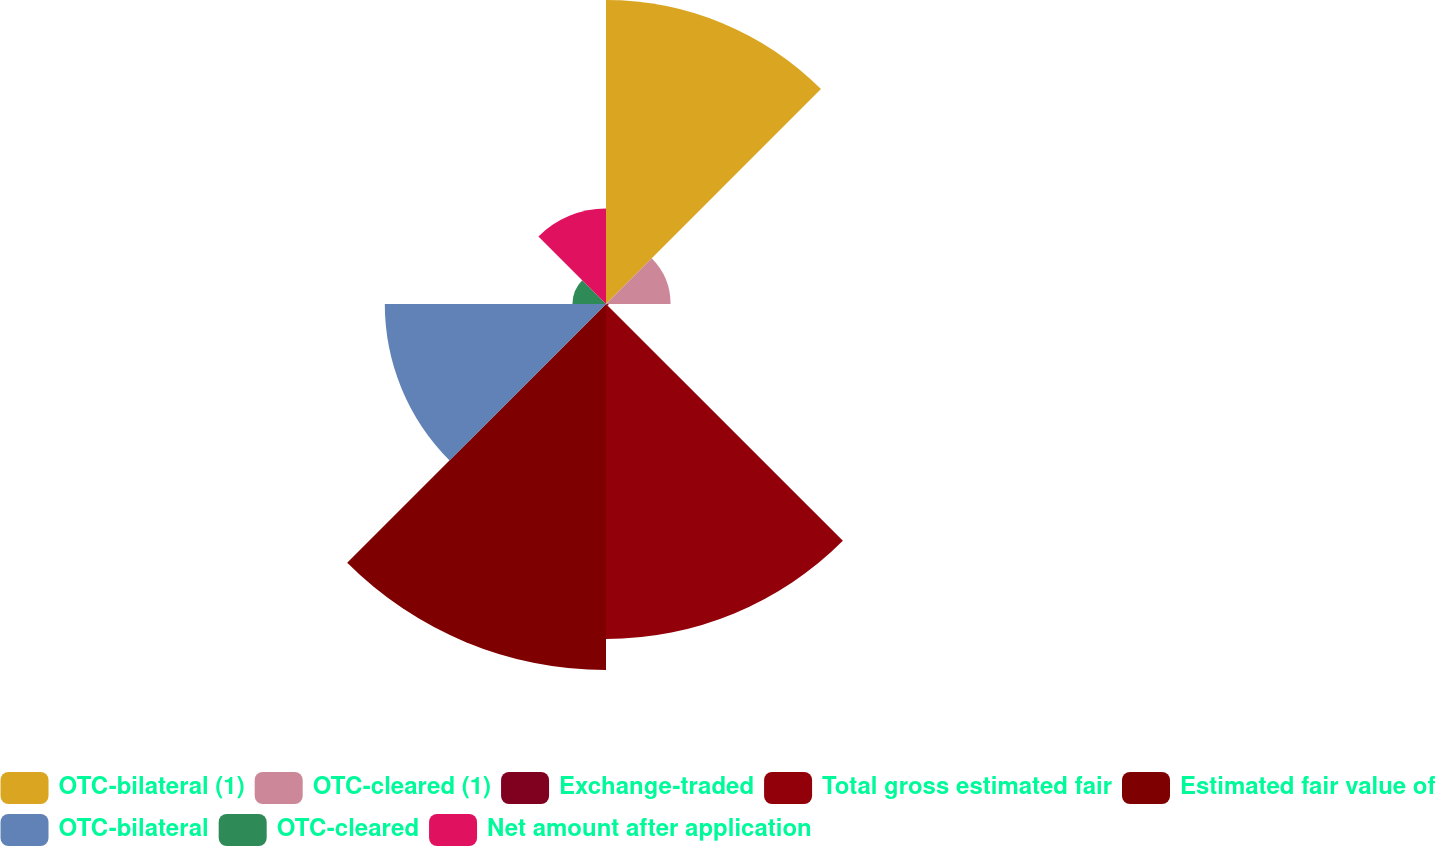Convert chart. <chart><loc_0><loc_0><loc_500><loc_500><pie_chart><fcel>OTC-bilateral (1)<fcel>OTC-cleared (1)<fcel>Exchange-traded<fcel>Total gross estimated fair<fcel>Estimated fair value of<fcel>OTC-bilateral<fcel>OTC-cleared<fcel>Net amount after application<nl><fcel>21.37%<fcel>4.54%<fcel>0.18%<fcel>23.55%<fcel>25.73%<fcel>15.55%<fcel>2.36%<fcel>6.72%<nl></chart> 